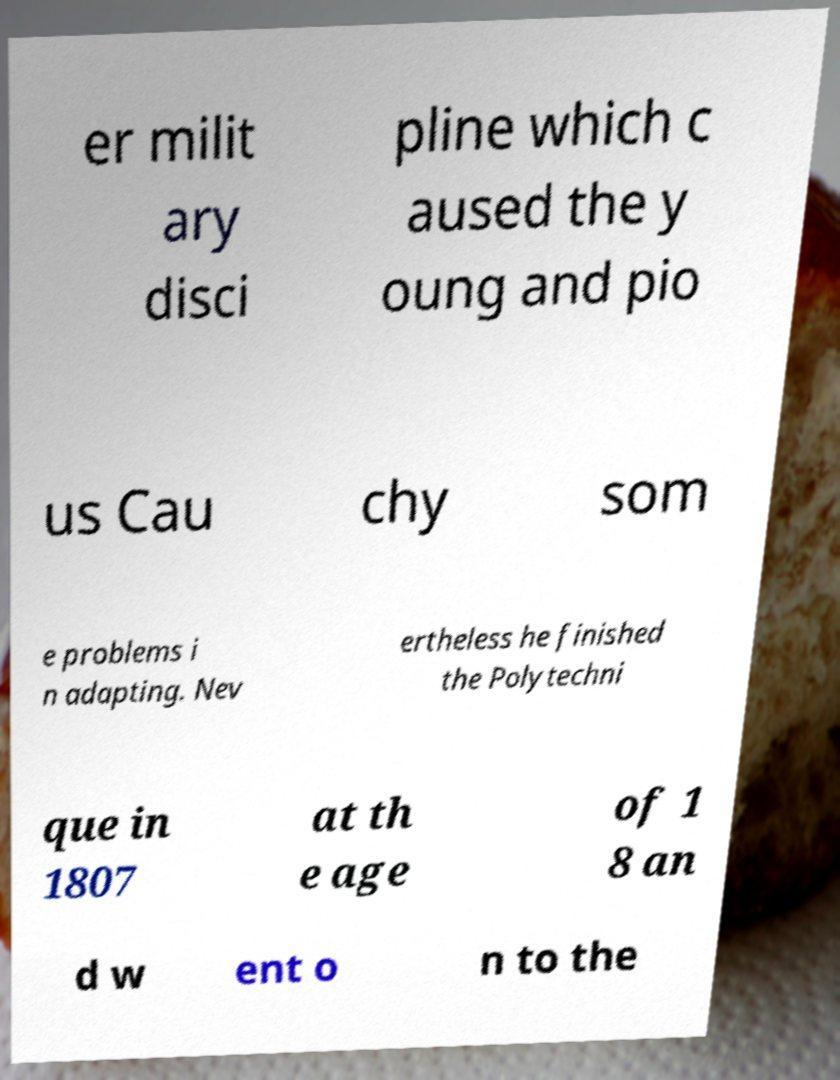There's text embedded in this image that I need extracted. Can you transcribe it verbatim? er milit ary disci pline which c aused the y oung and pio us Cau chy som e problems i n adapting. Nev ertheless he finished the Polytechni que in 1807 at th e age of 1 8 an d w ent o n to the 